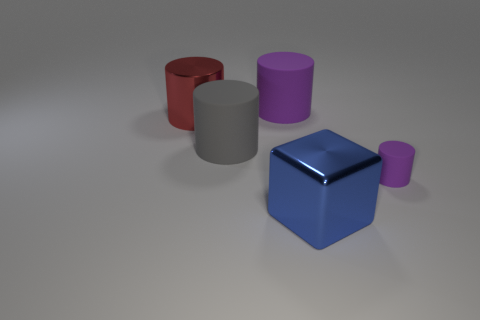What is the shape of the large thing that is the same color as the tiny cylinder?
Make the answer very short. Cylinder. What number of blue metal blocks are the same size as the shiny cylinder?
Offer a terse response. 1. How many gray things are tiny rubber blocks or big shiny cubes?
Give a very brief answer. 0. There is a thing in front of the purple rubber thing that is in front of the large purple matte cylinder; what shape is it?
Offer a very short reply. Cube. What shape is the blue metal object that is the same size as the gray thing?
Your answer should be compact. Cube. Is there a big block of the same color as the tiny cylinder?
Provide a succinct answer. No. Are there an equal number of rubber objects that are on the left side of the red metal thing and gray matte objects that are on the right side of the gray cylinder?
Provide a short and direct response. Yes. There is a tiny thing; is its shape the same as the purple object that is behind the tiny purple cylinder?
Provide a succinct answer. Yes. What number of other things are there of the same material as the large purple cylinder
Make the answer very short. 2. There is a tiny purple cylinder; are there any objects to the left of it?
Offer a terse response. Yes. 